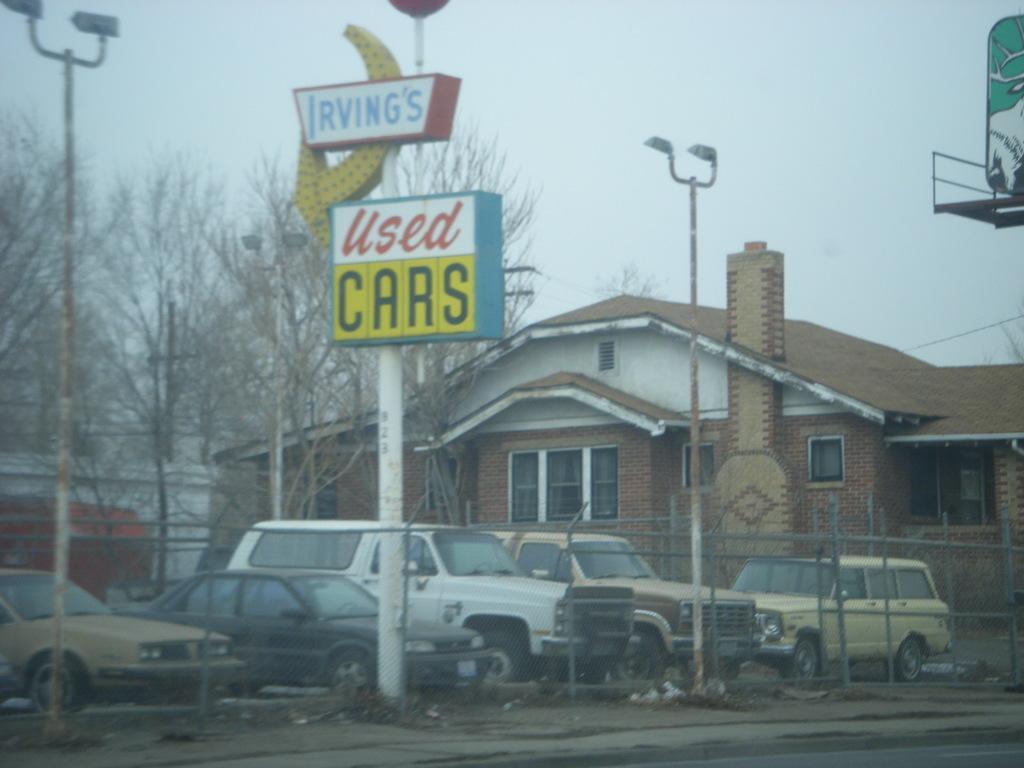Could you give a brief overview of what you see in this image? In this image I can see few cars. I can see a building. There are few trees. I can see a pole. I can see a board with some text. 